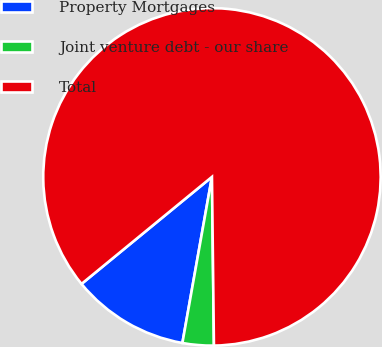Convert chart. <chart><loc_0><loc_0><loc_500><loc_500><pie_chart><fcel>Property Mortgages<fcel>Joint venture debt - our share<fcel>Total<nl><fcel>11.26%<fcel>2.99%<fcel>85.75%<nl></chart> 